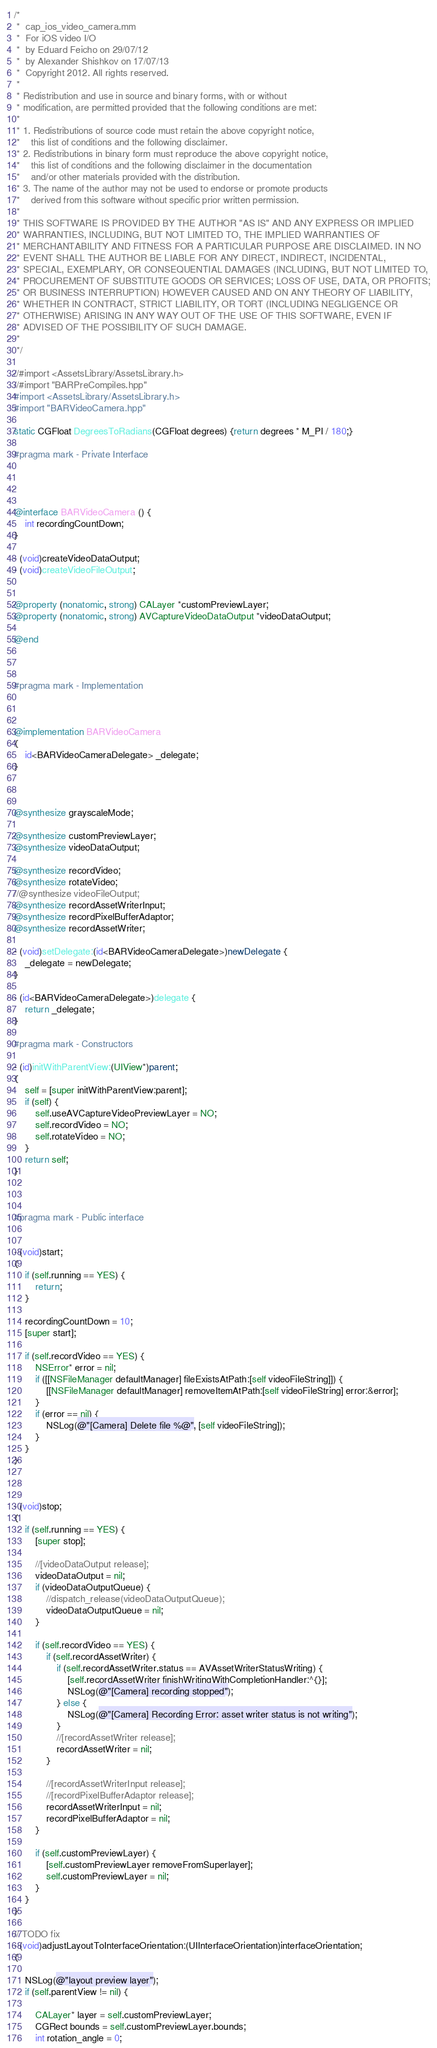Convert code to text. <code><loc_0><loc_0><loc_500><loc_500><_ObjectiveC_>/*
 *  cap_ios_video_camera.mm
 *  For iOS video I/O
 *  by Eduard Feicho on 29/07/12
 *  by Alexander Shishkov on 17/07/13
 *  Copyright 2012. All rights reserved.
 *
 * Redistribution and use in source and binary forms, with or without
 * modification, are permitted provided that the following conditions are met:
 *
 * 1. Redistributions of source code must retain the above copyright notice,
 *    this list of conditions and the following disclaimer.
 * 2. Redistributions in binary form must reproduce the above copyright notice,
 *    this list of conditions and the following disclaimer in the documentation
 *    and/or other materials provided with the distribution.
 * 3. The name of the author may not be used to endorse or promote products
 *    derived from this software without specific prior written permission.
 *
 * THIS SOFTWARE IS PROVIDED BY THE AUTHOR "AS IS" AND ANY EXPRESS OR IMPLIED
 * WARRANTIES, INCLUDING, BUT NOT LIMITED TO, THE IMPLIED WARRANTIES OF
 * MERCHANTABILITY AND FITNESS FOR A PARTICULAR PURPOSE ARE DISCLAIMED. IN NO
 * EVENT SHALL THE AUTHOR BE LIABLE FOR ANY DIRECT, INDIRECT, INCIDENTAL,
 * SPECIAL, EXEMPLARY, OR CONSEQUENTIAL DAMAGES (INCLUDING, BUT NOT LIMITED TO,
 * PROCUREMENT OF SUBSTITUTE GOODS OR SERVICES; LOSS OF USE, DATA, OR PROFITS;
 * OR BUSINESS INTERRUPTION) HOWEVER CAUSED AND ON ANY THEORY OF LIABILITY,
 * WHETHER IN CONTRACT, STRICT LIABILITY, OR TORT (INCLUDING NEGLIGENCE OR
 * OTHERWISE) ARISING IN ANY WAY OUT OF THE USE OF THIS SOFTWARE, EVEN IF
 * ADVISED OF THE POSSIBILITY OF SUCH DAMAGE.
 *
 */

//#import <AssetsLibrary/AssetsLibrary.h>
//#import "BARPreCompiles.hpp"
#import <AssetsLibrary/AssetsLibrary.h>
#import "BARVideoCamera.hpp"

static CGFloat DegreesToRadians(CGFloat degrees) {return degrees * M_PI / 180;}

#pragma mark - Private Interface




@interface BARVideoCamera () {
    int recordingCountDown;
}

- (void)createVideoDataOutput;
- (void)createVideoFileOutput;


@property (nonatomic, strong) CALayer *customPreviewLayer;
@property (nonatomic, strong) AVCaptureVideoDataOutput *videoDataOutput;

@end



#pragma mark - Implementation



@implementation BARVideoCamera
{
    id<BARVideoCameraDelegate> _delegate;
}



@synthesize grayscaleMode;

@synthesize customPreviewLayer;
@synthesize videoDataOutput;

@synthesize recordVideo;
@synthesize rotateVideo;
//@synthesize videoFileOutput;
@synthesize recordAssetWriterInput;
@synthesize recordPixelBufferAdaptor;
@synthesize recordAssetWriter;

- (void)setDelegate:(id<BARVideoCameraDelegate>)newDelegate {
    _delegate = newDelegate;
}

- (id<BARVideoCameraDelegate>)delegate {
    return _delegate;
}

#pragma mark - Constructors

- (id)initWithParentView:(UIView*)parent;
{
    self = [super initWithParentView:parent];
    if (self) {
        self.useAVCaptureVideoPreviewLayer = NO;
        self.recordVideo = NO;
        self.rotateVideo = NO;
    }
    return self;
}



#pragma mark - Public interface


- (void)start;
{
    if (self.running == YES) {
        return;
    }
    
    recordingCountDown = 10;
    [super start];
    
    if (self.recordVideo == YES) {
        NSError* error = nil;
        if ([[NSFileManager defaultManager] fileExistsAtPath:[self videoFileString]]) {
            [[NSFileManager defaultManager] removeItemAtPath:[self videoFileString] error:&error];
        }
        if (error == nil) {
            NSLog(@"[Camera] Delete file %@", [self videoFileString]);
        }
    }
}



- (void)stop;
{
    if (self.running == YES) {
        [super stop];
        
        //[videoDataOutput release];
        videoDataOutput = nil;
        if (videoDataOutputQueue) {
            //dispatch_release(videoDataOutputQueue);
            videoDataOutputQueue = nil;
        }
        
        if (self.recordVideo == YES) {
            if (self.recordAssetWriter) {
                if (self.recordAssetWriter.status == AVAssetWriterStatusWriting) {
                    [self.recordAssetWriter finishWritingWithCompletionHandler:^{}];
                    NSLog(@"[Camera] recording stopped");
                } else {
                    NSLog(@"[Camera] Recording Error: asset writer status is not writing");
                }
                //[recordAssetWriter release];
                recordAssetWriter = nil;
            }
            
            //[recordAssetWriterInput release];
            //[recordPixelBufferAdaptor release];
            recordAssetWriterInput = nil;
            recordPixelBufferAdaptor = nil;
        }
        
        if (self.customPreviewLayer) {
            [self.customPreviewLayer removeFromSuperlayer];
            self.customPreviewLayer = nil;
        }
    }
}

// TODO fix
- (void)adjustLayoutToInterfaceOrientation:(UIInterfaceOrientation)interfaceOrientation;
{
    
    NSLog(@"layout preview layer");
    if (self.parentView != nil) {
        
        CALayer* layer = self.customPreviewLayer;
        CGRect bounds = self.customPreviewLayer.bounds;
        int rotation_angle = 0;</code> 